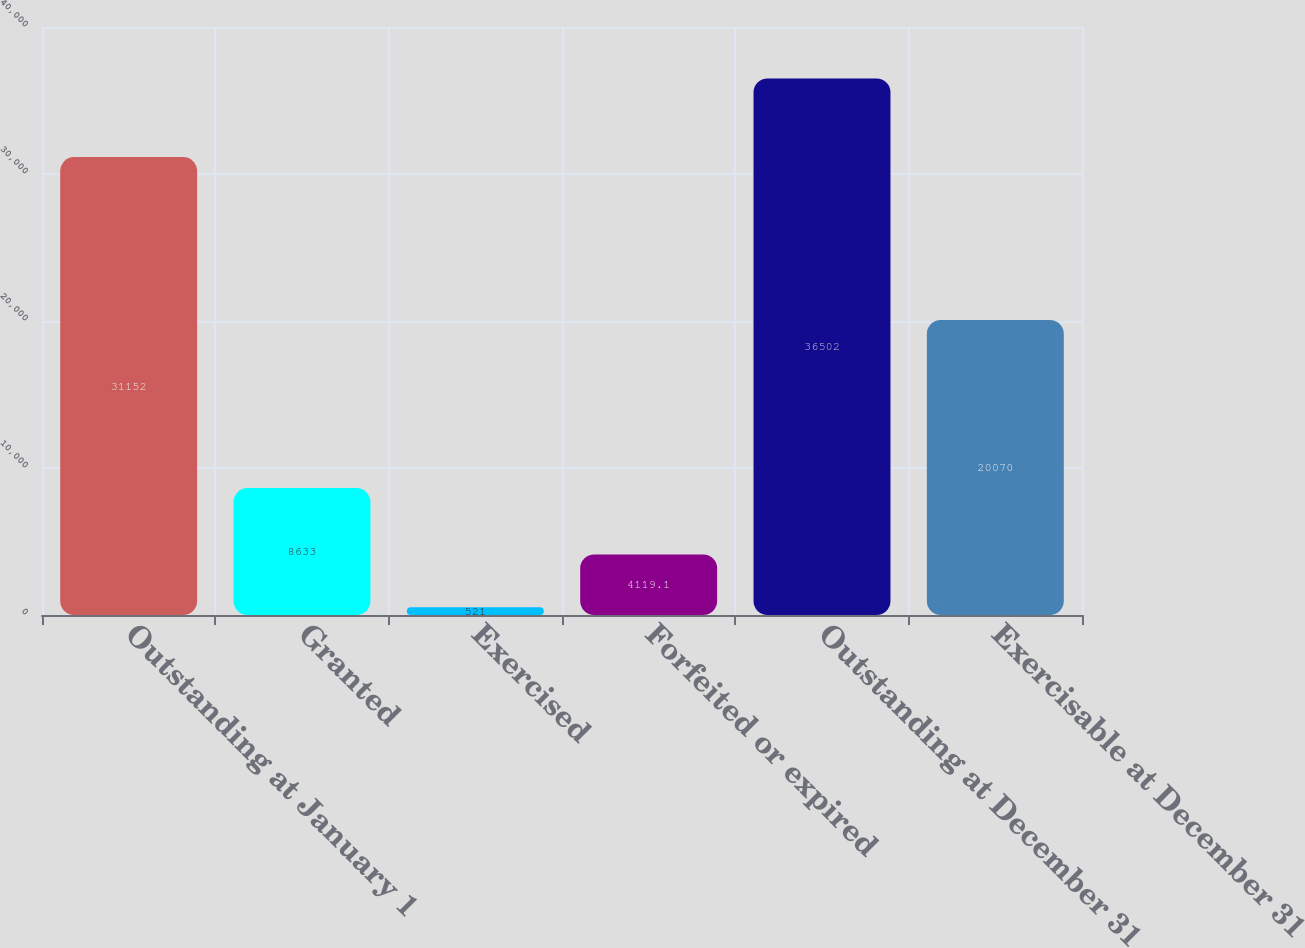Convert chart. <chart><loc_0><loc_0><loc_500><loc_500><bar_chart><fcel>Outstanding at January 1<fcel>Granted<fcel>Exercised<fcel>Forfeited or expired<fcel>Outstanding at December 31<fcel>Exercisable at December 31<nl><fcel>31152<fcel>8633<fcel>521<fcel>4119.1<fcel>36502<fcel>20070<nl></chart> 